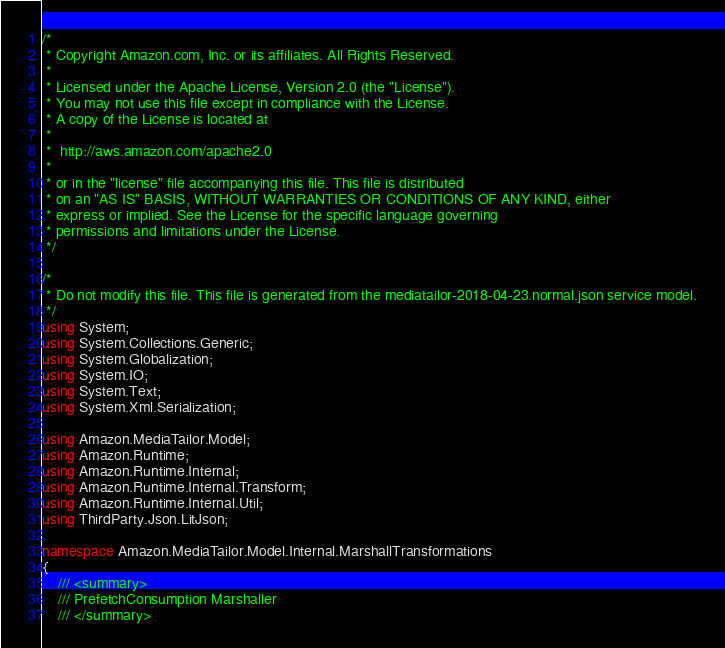<code> <loc_0><loc_0><loc_500><loc_500><_C#_>/*
 * Copyright Amazon.com, Inc. or its affiliates. All Rights Reserved.
 * 
 * Licensed under the Apache License, Version 2.0 (the "License").
 * You may not use this file except in compliance with the License.
 * A copy of the License is located at
 * 
 *  http://aws.amazon.com/apache2.0
 * 
 * or in the "license" file accompanying this file. This file is distributed
 * on an "AS IS" BASIS, WITHOUT WARRANTIES OR CONDITIONS OF ANY KIND, either
 * express or implied. See the License for the specific language governing
 * permissions and limitations under the License.
 */

/*
 * Do not modify this file. This file is generated from the mediatailor-2018-04-23.normal.json service model.
 */
using System;
using System.Collections.Generic;
using System.Globalization;
using System.IO;
using System.Text;
using System.Xml.Serialization;

using Amazon.MediaTailor.Model;
using Amazon.Runtime;
using Amazon.Runtime.Internal;
using Amazon.Runtime.Internal.Transform;
using Amazon.Runtime.Internal.Util;
using ThirdParty.Json.LitJson;

namespace Amazon.MediaTailor.Model.Internal.MarshallTransformations
{
    /// <summary>
    /// PrefetchConsumption Marshaller
    /// </summary>       </code> 